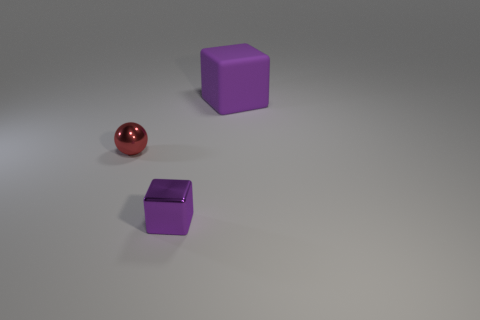Is there any other thing that is the same color as the metallic sphere?
Your answer should be compact. No. What is the material of the red thing?
Provide a succinct answer. Metal. There is a purple object on the left side of the object that is behind the metal thing behind the small purple thing; what is its shape?
Your answer should be compact. Cube. Is the number of small shiny spheres on the right side of the purple metal thing greater than the number of large things?
Your answer should be very brief. No. There is a large object; is its shape the same as the small object that is behind the tiny metallic block?
Give a very brief answer. No. There is a tiny thing that is the same color as the large matte block; what shape is it?
Keep it short and to the point. Cube. There is a large purple rubber object behind the purple object that is in front of the rubber object; what number of objects are in front of it?
Provide a short and direct response. 2. What color is the metallic sphere that is the same size as the purple metal cube?
Your response must be concise. Red. There is a thing that is in front of the thing on the left side of the small purple object; how big is it?
Give a very brief answer. Small. The thing that is the same color as the tiny cube is what size?
Your answer should be compact. Large. 